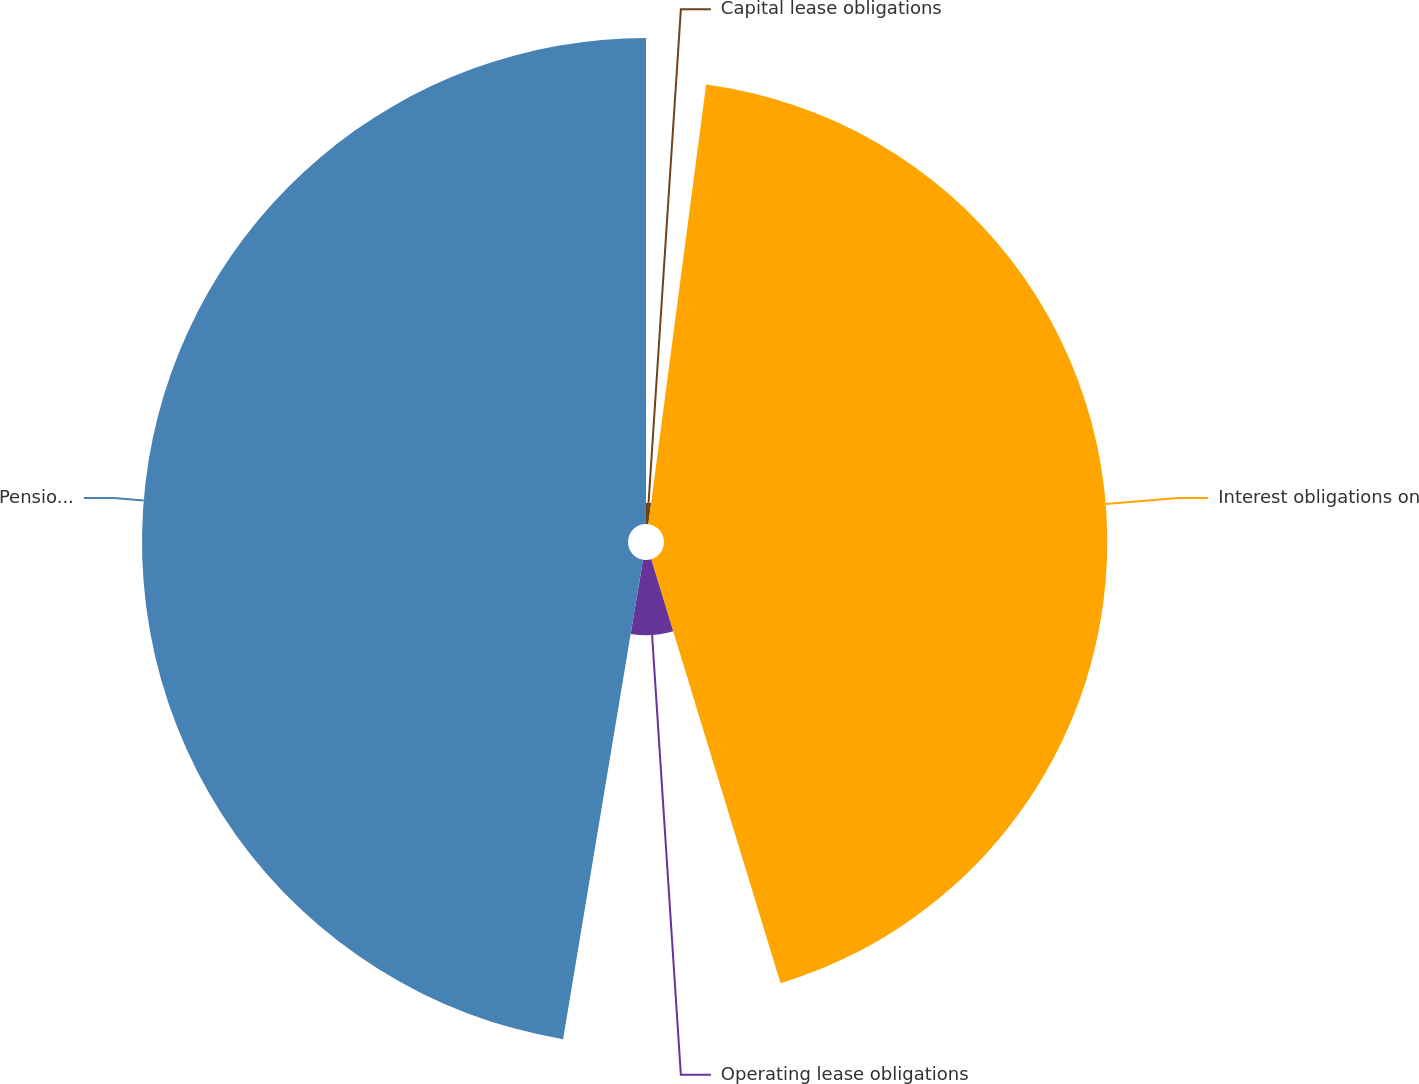Convert chart. <chart><loc_0><loc_0><loc_500><loc_500><pie_chart><fcel>Capital lease obligations<fcel>Interest obligations on<fcel>Operating lease obligations<fcel>Pension and other post-<nl><fcel>2.08%<fcel>43.21%<fcel>7.34%<fcel>47.37%<nl></chart> 